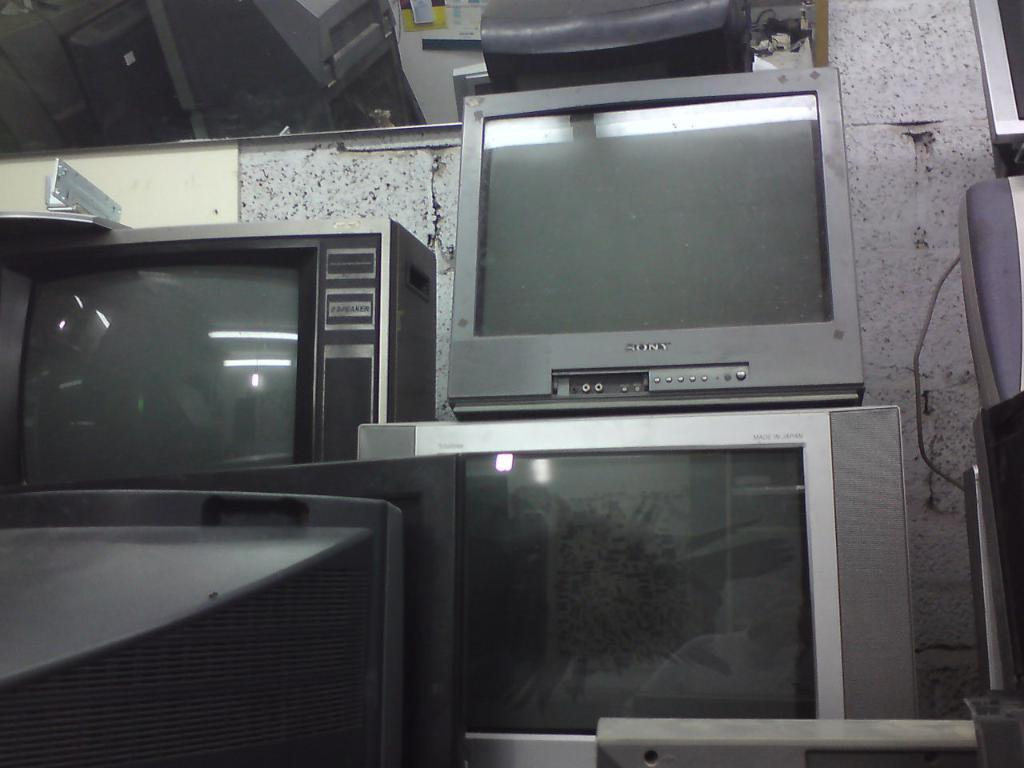<image>
Share a concise interpretation of the image provided. Many old televisions being put on display including one from Sony. 